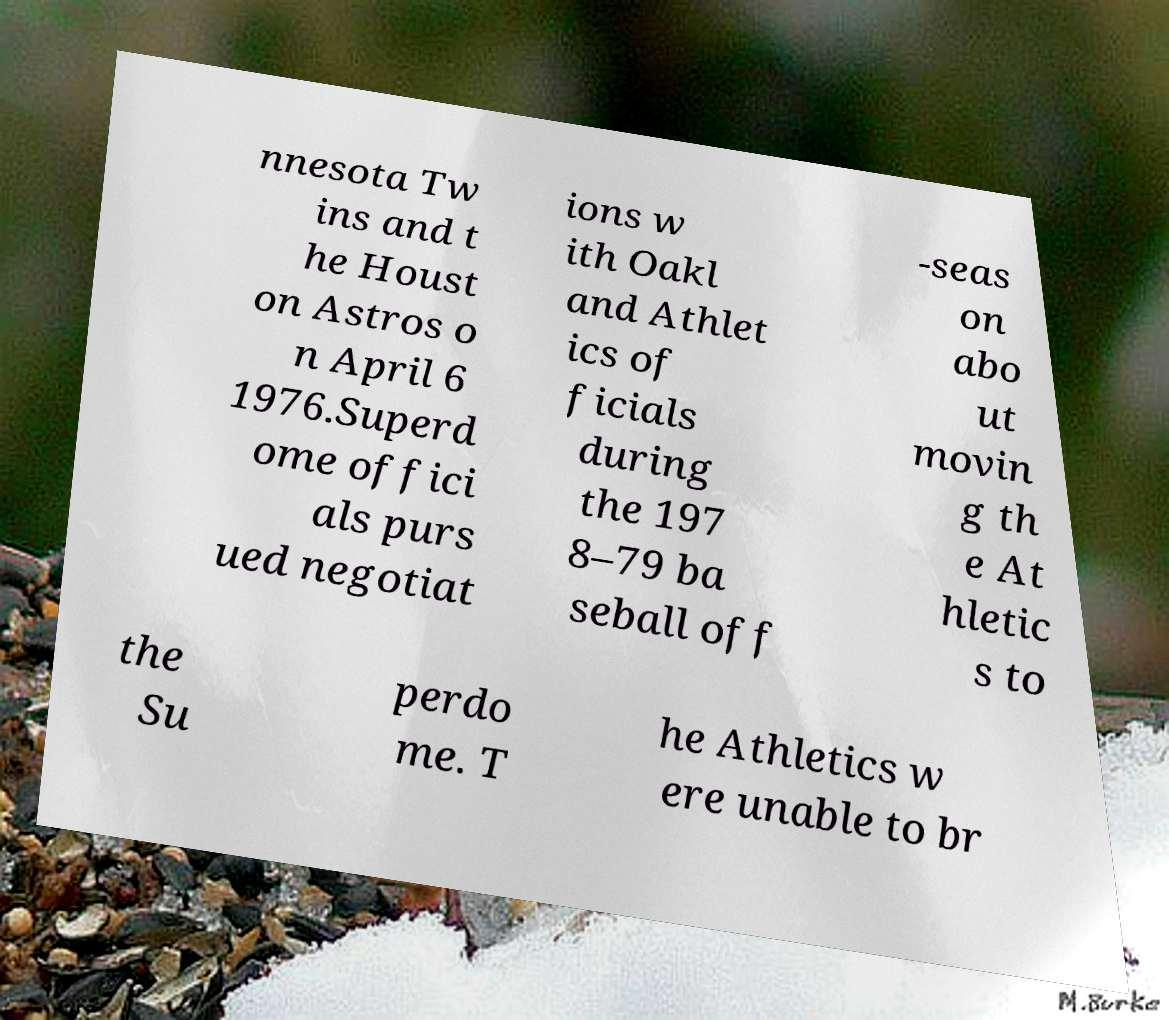Could you assist in decoding the text presented in this image and type it out clearly? nnesota Tw ins and t he Houst on Astros o n April 6 1976.Superd ome offici als purs ued negotiat ions w ith Oakl and Athlet ics of ficials during the 197 8–79 ba seball off -seas on abo ut movin g th e At hletic s to the Su perdo me. T he Athletics w ere unable to br 